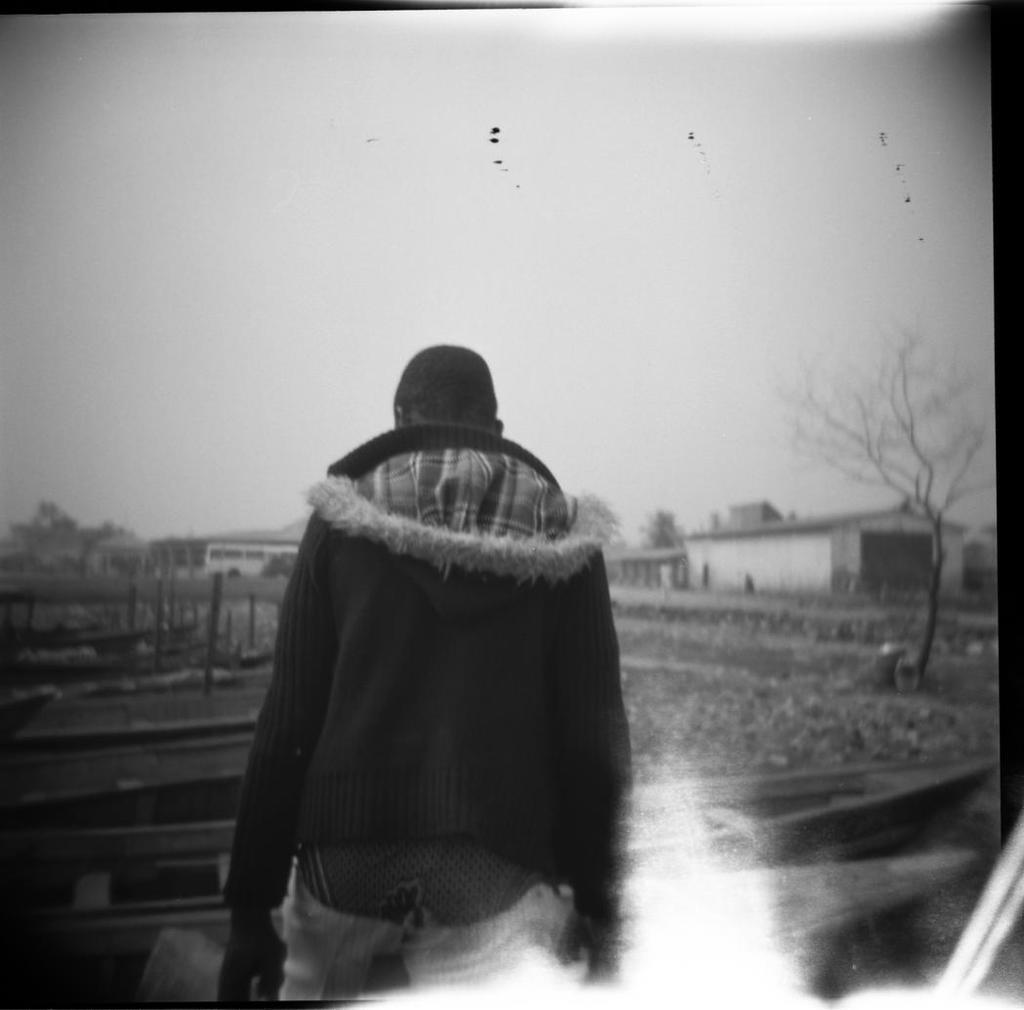What is the main subject of the image? There is a person standing in the image. What is in front of the person? There are boards in front of the person. What type of terrain is visible in the image? Grass is present in the image. What other objects can be seen in the image? Wooden rods are visible in the image. What can be seen in the distance in the image? There are houses and trees in the background of the image. Can you tell me how many thumbs the goose has in the image? There is no goose present in the image, so it is not possible to determine the number of thumbs it might have. 